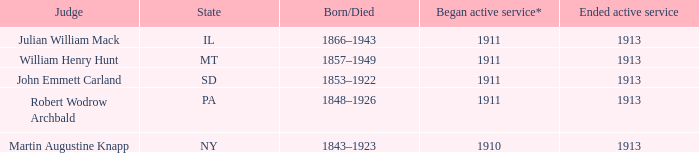Who was the judge for the state SD? John Emmett Carland. Could you parse the entire table as a dict? {'header': ['Judge', 'State', 'Born/Died', 'Began active service*', 'Ended active service'], 'rows': [['Julian William Mack', 'IL', '1866–1943', '1911', '1913'], ['William Henry Hunt', 'MT', '1857–1949', '1911', '1913'], ['John Emmett Carland', 'SD', '1853–1922', '1911', '1913'], ['Robert Wodrow Archbald', 'PA', '1848–1926', '1911', '1913'], ['Martin Augustine Knapp', 'NY', '1843–1923', '1910', '1913']]} 